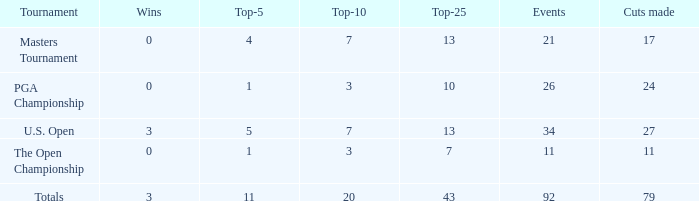Name the sum of top-25 for pga championship and top-5 less than 1 None. Parse the table in full. {'header': ['Tournament', 'Wins', 'Top-5', 'Top-10', 'Top-25', 'Events', 'Cuts made'], 'rows': [['Masters Tournament', '0', '4', '7', '13', '21', '17'], ['PGA Championship', '0', '1', '3', '10', '26', '24'], ['U.S. Open', '3', '5', '7', '13', '34', '27'], ['The Open Championship', '0', '1', '3', '7', '11', '11'], ['Totals', '3', '11', '20', '43', '92', '79']]} 